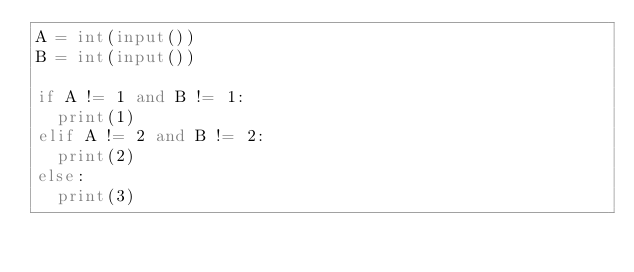Convert code to text. <code><loc_0><loc_0><loc_500><loc_500><_Python_>A = int(input())
B = int(input())

if A != 1 and B != 1:
  print(1)
elif A != 2 and B != 2:
  print(2)
else:
  print(3)</code> 